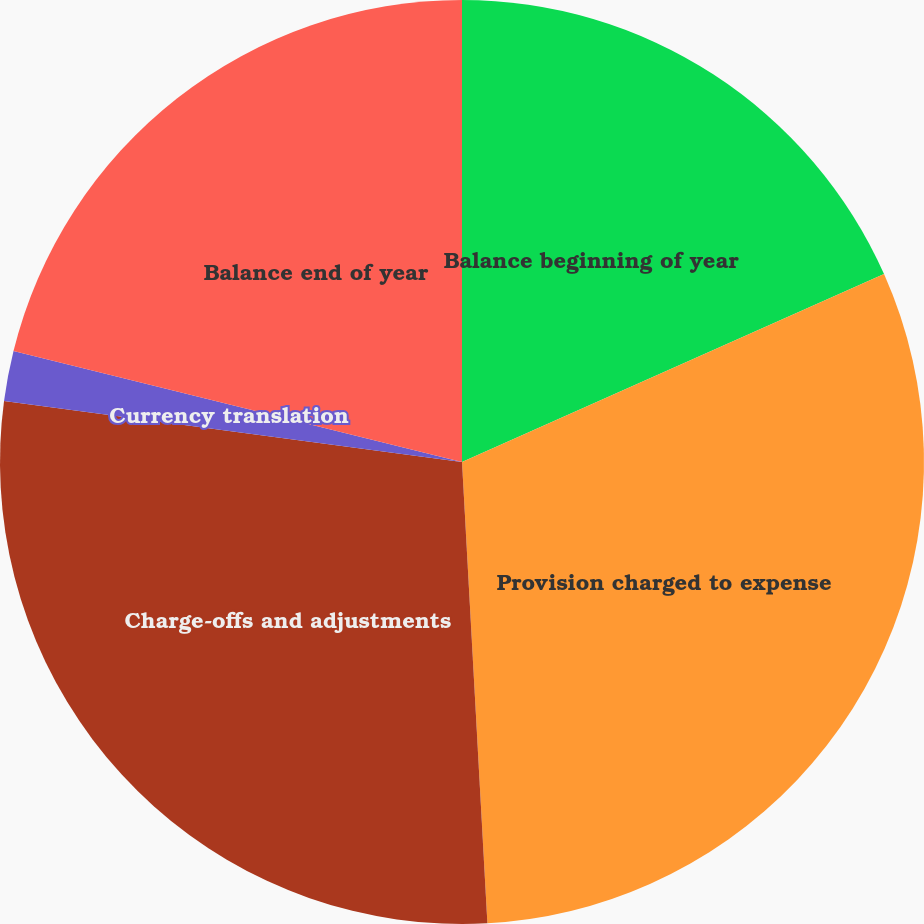Convert chart. <chart><loc_0><loc_0><loc_500><loc_500><pie_chart><fcel>Balance beginning of year<fcel>Provision charged to expense<fcel>Charge-offs and adjustments<fcel>Currency translation<fcel>Balance end of year<nl><fcel>18.33%<fcel>30.79%<fcel>27.98%<fcel>1.75%<fcel>21.14%<nl></chart> 